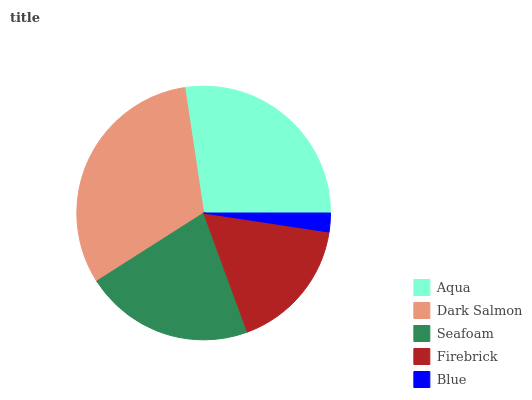Is Blue the minimum?
Answer yes or no. Yes. Is Dark Salmon the maximum?
Answer yes or no. Yes. Is Seafoam the minimum?
Answer yes or no. No. Is Seafoam the maximum?
Answer yes or no. No. Is Dark Salmon greater than Seafoam?
Answer yes or no. Yes. Is Seafoam less than Dark Salmon?
Answer yes or no. Yes. Is Seafoam greater than Dark Salmon?
Answer yes or no. No. Is Dark Salmon less than Seafoam?
Answer yes or no. No. Is Seafoam the high median?
Answer yes or no. Yes. Is Seafoam the low median?
Answer yes or no. Yes. Is Blue the high median?
Answer yes or no. No. Is Aqua the low median?
Answer yes or no. No. 